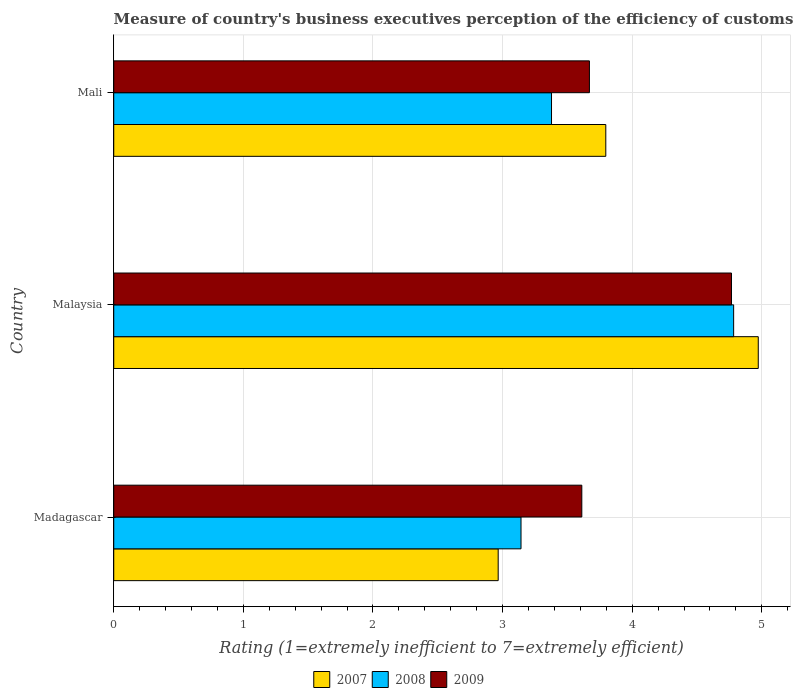How many different coloured bars are there?
Keep it short and to the point. 3. How many groups of bars are there?
Your answer should be very brief. 3. How many bars are there on the 3rd tick from the top?
Your response must be concise. 3. What is the label of the 2nd group of bars from the top?
Your answer should be very brief. Malaysia. In how many cases, is the number of bars for a given country not equal to the number of legend labels?
Your response must be concise. 0. What is the rating of the efficiency of customs procedure in 2007 in Madagascar?
Keep it short and to the point. 2.97. Across all countries, what is the maximum rating of the efficiency of customs procedure in 2009?
Give a very brief answer. 4.77. Across all countries, what is the minimum rating of the efficiency of customs procedure in 2008?
Your response must be concise. 3.14. In which country was the rating of the efficiency of customs procedure in 2008 maximum?
Offer a very short reply. Malaysia. In which country was the rating of the efficiency of customs procedure in 2007 minimum?
Offer a terse response. Madagascar. What is the total rating of the efficiency of customs procedure in 2008 in the graph?
Provide a short and direct response. 11.3. What is the difference between the rating of the efficiency of customs procedure in 2008 in Madagascar and that in Mali?
Your answer should be very brief. -0.24. What is the difference between the rating of the efficiency of customs procedure in 2009 in Malaysia and the rating of the efficiency of customs procedure in 2007 in Mali?
Give a very brief answer. 0.97. What is the average rating of the efficiency of customs procedure in 2007 per country?
Make the answer very short. 3.91. What is the difference between the rating of the efficiency of customs procedure in 2008 and rating of the efficiency of customs procedure in 2007 in Malaysia?
Give a very brief answer. -0.19. What is the ratio of the rating of the efficiency of customs procedure in 2008 in Madagascar to that in Mali?
Your answer should be very brief. 0.93. Is the rating of the efficiency of customs procedure in 2008 in Madagascar less than that in Mali?
Provide a short and direct response. Yes. What is the difference between the highest and the second highest rating of the efficiency of customs procedure in 2009?
Your answer should be very brief. 1.1. What is the difference between the highest and the lowest rating of the efficiency of customs procedure in 2008?
Your response must be concise. 1.64. In how many countries, is the rating of the efficiency of customs procedure in 2009 greater than the average rating of the efficiency of customs procedure in 2009 taken over all countries?
Your answer should be very brief. 1. Is the sum of the rating of the efficiency of customs procedure in 2007 in Malaysia and Mali greater than the maximum rating of the efficiency of customs procedure in 2009 across all countries?
Offer a terse response. Yes. What is the difference between two consecutive major ticks on the X-axis?
Give a very brief answer. 1. Does the graph contain grids?
Offer a very short reply. Yes. What is the title of the graph?
Make the answer very short. Measure of country's business executives perception of the efficiency of customs procedures. What is the label or title of the X-axis?
Keep it short and to the point. Rating (1=extremely inefficient to 7=extremely efficient). What is the Rating (1=extremely inefficient to 7=extremely efficient) of 2007 in Madagascar?
Your answer should be very brief. 2.97. What is the Rating (1=extremely inefficient to 7=extremely efficient) in 2008 in Madagascar?
Make the answer very short. 3.14. What is the Rating (1=extremely inefficient to 7=extremely efficient) of 2009 in Madagascar?
Offer a terse response. 3.61. What is the Rating (1=extremely inefficient to 7=extremely efficient) in 2007 in Malaysia?
Your answer should be compact. 4.97. What is the Rating (1=extremely inefficient to 7=extremely efficient) of 2008 in Malaysia?
Give a very brief answer. 4.78. What is the Rating (1=extremely inefficient to 7=extremely efficient) of 2009 in Malaysia?
Make the answer very short. 4.77. What is the Rating (1=extremely inefficient to 7=extremely efficient) of 2007 in Mali?
Your answer should be compact. 3.8. What is the Rating (1=extremely inefficient to 7=extremely efficient) of 2008 in Mali?
Provide a succinct answer. 3.38. What is the Rating (1=extremely inefficient to 7=extremely efficient) of 2009 in Mali?
Ensure brevity in your answer.  3.67. Across all countries, what is the maximum Rating (1=extremely inefficient to 7=extremely efficient) in 2007?
Your answer should be compact. 4.97. Across all countries, what is the maximum Rating (1=extremely inefficient to 7=extremely efficient) of 2008?
Ensure brevity in your answer.  4.78. Across all countries, what is the maximum Rating (1=extremely inefficient to 7=extremely efficient) of 2009?
Your answer should be very brief. 4.77. Across all countries, what is the minimum Rating (1=extremely inefficient to 7=extremely efficient) in 2007?
Offer a very short reply. 2.97. Across all countries, what is the minimum Rating (1=extremely inefficient to 7=extremely efficient) in 2008?
Make the answer very short. 3.14. Across all countries, what is the minimum Rating (1=extremely inefficient to 7=extremely efficient) of 2009?
Your answer should be very brief. 3.61. What is the total Rating (1=extremely inefficient to 7=extremely efficient) in 2007 in the graph?
Offer a very short reply. 11.74. What is the total Rating (1=extremely inefficient to 7=extremely efficient) in 2008 in the graph?
Keep it short and to the point. 11.3. What is the total Rating (1=extremely inefficient to 7=extremely efficient) in 2009 in the graph?
Your answer should be very brief. 12.05. What is the difference between the Rating (1=extremely inefficient to 7=extremely efficient) in 2007 in Madagascar and that in Malaysia?
Provide a succinct answer. -2.01. What is the difference between the Rating (1=extremely inefficient to 7=extremely efficient) of 2008 in Madagascar and that in Malaysia?
Your answer should be very brief. -1.64. What is the difference between the Rating (1=extremely inefficient to 7=extremely efficient) in 2009 in Madagascar and that in Malaysia?
Offer a very short reply. -1.15. What is the difference between the Rating (1=extremely inefficient to 7=extremely efficient) of 2007 in Madagascar and that in Mali?
Keep it short and to the point. -0.83. What is the difference between the Rating (1=extremely inefficient to 7=extremely efficient) in 2008 in Madagascar and that in Mali?
Provide a succinct answer. -0.24. What is the difference between the Rating (1=extremely inefficient to 7=extremely efficient) in 2009 in Madagascar and that in Mali?
Make the answer very short. -0.06. What is the difference between the Rating (1=extremely inefficient to 7=extremely efficient) of 2007 in Malaysia and that in Mali?
Offer a very short reply. 1.18. What is the difference between the Rating (1=extremely inefficient to 7=extremely efficient) in 2008 in Malaysia and that in Mali?
Your answer should be compact. 1.41. What is the difference between the Rating (1=extremely inefficient to 7=extremely efficient) of 2009 in Malaysia and that in Mali?
Your answer should be very brief. 1.1. What is the difference between the Rating (1=extremely inefficient to 7=extremely efficient) in 2007 in Madagascar and the Rating (1=extremely inefficient to 7=extremely efficient) in 2008 in Malaysia?
Your response must be concise. -1.82. What is the difference between the Rating (1=extremely inefficient to 7=extremely efficient) of 2007 in Madagascar and the Rating (1=extremely inefficient to 7=extremely efficient) of 2009 in Malaysia?
Provide a short and direct response. -1.8. What is the difference between the Rating (1=extremely inefficient to 7=extremely efficient) in 2008 in Madagascar and the Rating (1=extremely inefficient to 7=extremely efficient) in 2009 in Malaysia?
Ensure brevity in your answer.  -1.62. What is the difference between the Rating (1=extremely inefficient to 7=extremely efficient) in 2007 in Madagascar and the Rating (1=extremely inefficient to 7=extremely efficient) in 2008 in Mali?
Provide a short and direct response. -0.41. What is the difference between the Rating (1=extremely inefficient to 7=extremely efficient) of 2007 in Madagascar and the Rating (1=extremely inefficient to 7=extremely efficient) of 2009 in Mali?
Ensure brevity in your answer.  -0.7. What is the difference between the Rating (1=extremely inefficient to 7=extremely efficient) in 2008 in Madagascar and the Rating (1=extremely inefficient to 7=extremely efficient) in 2009 in Mali?
Keep it short and to the point. -0.53. What is the difference between the Rating (1=extremely inefficient to 7=extremely efficient) in 2007 in Malaysia and the Rating (1=extremely inefficient to 7=extremely efficient) in 2008 in Mali?
Provide a short and direct response. 1.6. What is the difference between the Rating (1=extremely inefficient to 7=extremely efficient) in 2007 in Malaysia and the Rating (1=extremely inefficient to 7=extremely efficient) in 2009 in Mali?
Ensure brevity in your answer.  1.3. What is the difference between the Rating (1=extremely inefficient to 7=extremely efficient) of 2008 in Malaysia and the Rating (1=extremely inefficient to 7=extremely efficient) of 2009 in Mali?
Offer a terse response. 1.11. What is the average Rating (1=extremely inefficient to 7=extremely efficient) of 2007 per country?
Ensure brevity in your answer.  3.91. What is the average Rating (1=extremely inefficient to 7=extremely efficient) of 2008 per country?
Keep it short and to the point. 3.77. What is the average Rating (1=extremely inefficient to 7=extremely efficient) of 2009 per country?
Your response must be concise. 4.02. What is the difference between the Rating (1=extremely inefficient to 7=extremely efficient) in 2007 and Rating (1=extremely inefficient to 7=extremely efficient) in 2008 in Madagascar?
Make the answer very short. -0.18. What is the difference between the Rating (1=extremely inefficient to 7=extremely efficient) in 2007 and Rating (1=extremely inefficient to 7=extremely efficient) in 2009 in Madagascar?
Your answer should be compact. -0.65. What is the difference between the Rating (1=extremely inefficient to 7=extremely efficient) of 2008 and Rating (1=extremely inefficient to 7=extremely efficient) of 2009 in Madagascar?
Ensure brevity in your answer.  -0.47. What is the difference between the Rating (1=extremely inefficient to 7=extremely efficient) in 2007 and Rating (1=extremely inefficient to 7=extremely efficient) in 2008 in Malaysia?
Your answer should be very brief. 0.19. What is the difference between the Rating (1=extremely inefficient to 7=extremely efficient) in 2007 and Rating (1=extremely inefficient to 7=extremely efficient) in 2009 in Malaysia?
Provide a short and direct response. 0.21. What is the difference between the Rating (1=extremely inefficient to 7=extremely efficient) in 2008 and Rating (1=extremely inefficient to 7=extremely efficient) in 2009 in Malaysia?
Offer a very short reply. 0.02. What is the difference between the Rating (1=extremely inefficient to 7=extremely efficient) of 2007 and Rating (1=extremely inefficient to 7=extremely efficient) of 2008 in Mali?
Your answer should be compact. 0.42. What is the difference between the Rating (1=extremely inefficient to 7=extremely efficient) in 2007 and Rating (1=extremely inefficient to 7=extremely efficient) in 2009 in Mali?
Ensure brevity in your answer.  0.13. What is the difference between the Rating (1=extremely inefficient to 7=extremely efficient) in 2008 and Rating (1=extremely inefficient to 7=extremely efficient) in 2009 in Mali?
Your response must be concise. -0.29. What is the ratio of the Rating (1=extremely inefficient to 7=extremely efficient) of 2007 in Madagascar to that in Malaysia?
Provide a short and direct response. 0.6. What is the ratio of the Rating (1=extremely inefficient to 7=extremely efficient) in 2008 in Madagascar to that in Malaysia?
Give a very brief answer. 0.66. What is the ratio of the Rating (1=extremely inefficient to 7=extremely efficient) of 2009 in Madagascar to that in Malaysia?
Offer a very short reply. 0.76. What is the ratio of the Rating (1=extremely inefficient to 7=extremely efficient) of 2007 in Madagascar to that in Mali?
Give a very brief answer. 0.78. What is the ratio of the Rating (1=extremely inefficient to 7=extremely efficient) in 2008 in Madagascar to that in Mali?
Offer a very short reply. 0.93. What is the ratio of the Rating (1=extremely inefficient to 7=extremely efficient) of 2007 in Malaysia to that in Mali?
Your answer should be compact. 1.31. What is the ratio of the Rating (1=extremely inefficient to 7=extremely efficient) in 2008 in Malaysia to that in Mali?
Your answer should be compact. 1.42. What is the ratio of the Rating (1=extremely inefficient to 7=extremely efficient) in 2009 in Malaysia to that in Mali?
Provide a succinct answer. 1.3. What is the difference between the highest and the second highest Rating (1=extremely inefficient to 7=extremely efficient) of 2007?
Ensure brevity in your answer.  1.18. What is the difference between the highest and the second highest Rating (1=extremely inefficient to 7=extremely efficient) in 2008?
Give a very brief answer. 1.41. What is the difference between the highest and the second highest Rating (1=extremely inefficient to 7=extremely efficient) of 2009?
Offer a terse response. 1.1. What is the difference between the highest and the lowest Rating (1=extremely inefficient to 7=extremely efficient) of 2007?
Your answer should be very brief. 2.01. What is the difference between the highest and the lowest Rating (1=extremely inefficient to 7=extremely efficient) of 2008?
Provide a succinct answer. 1.64. What is the difference between the highest and the lowest Rating (1=extremely inefficient to 7=extremely efficient) in 2009?
Offer a terse response. 1.15. 